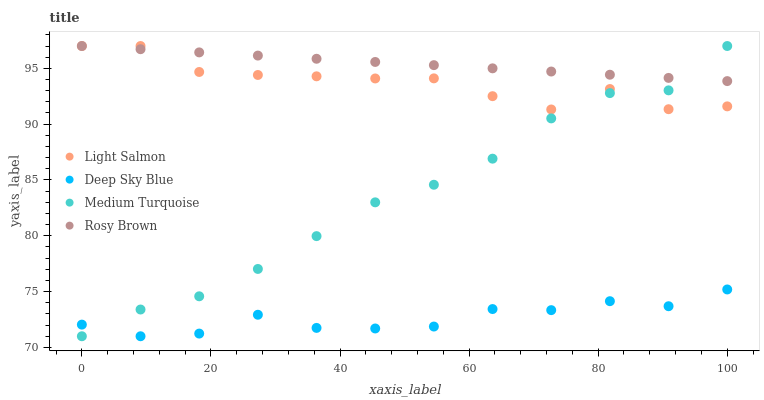Does Deep Sky Blue have the minimum area under the curve?
Answer yes or no. Yes. Does Rosy Brown have the maximum area under the curve?
Answer yes or no. Yes. Does Medium Turquoise have the minimum area under the curve?
Answer yes or no. No. Does Medium Turquoise have the maximum area under the curve?
Answer yes or no. No. Is Rosy Brown the smoothest?
Answer yes or no. Yes. Is Light Salmon the roughest?
Answer yes or no. Yes. Is Medium Turquoise the smoothest?
Answer yes or no. No. Is Medium Turquoise the roughest?
Answer yes or no. No. Does Medium Turquoise have the lowest value?
Answer yes or no. Yes. Does Rosy Brown have the lowest value?
Answer yes or no. No. Does Medium Turquoise have the highest value?
Answer yes or no. Yes. Does Deep Sky Blue have the highest value?
Answer yes or no. No. Is Deep Sky Blue less than Rosy Brown?
Answer yes or no. Yes. Is Light Salmon greater than Deep Sky Blue?
Answer yes or no. Yes. Does Medium Turquoise intersect Deep Sky Blue?
Answer yes or no. Yes. Is Medium Turquoise less than Deep Sky Blue?
Answer yes or no. No. Is Medium Turquoise greater than Deep Sky Blue?
Answer yes or no. No. Does Deep Sky Blue intersect Rosy Brown?
Answer yes or no. No. 